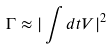Convert formula to latex. <formula><loc_0><loc_0><loc_500><loc_500>\Gamma \approx | \int { d t V } | ^ { 2 }</formula> 